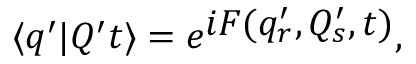<formula> <loc_0><loc_0><loc_500><loc_500>\langle q ^ { \prime } | Q ^ { \prime } t \rangle = e ^ { i F ( q _ { r } ^ { \prime } , Q _ { s } ^ { \prime } , t ) } ,</formula> 